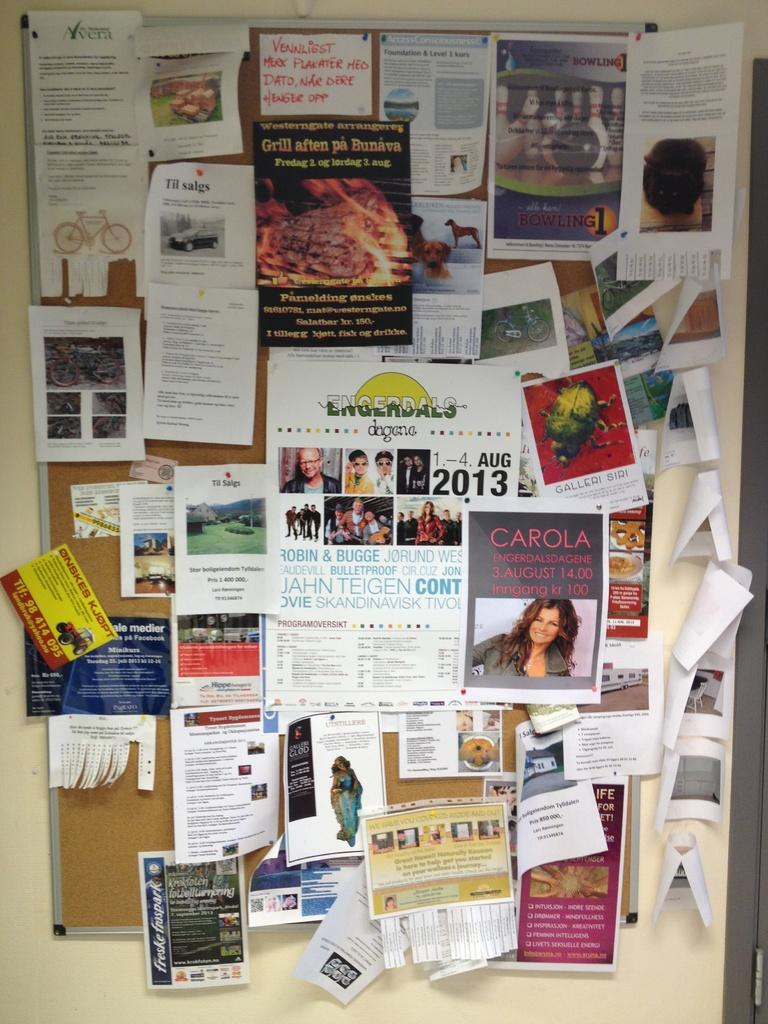<image>
Write a terse but informative summary of the picture. The cluttered bulletin board includes an announcement for 'Carola' on 3 August at 14:00. 